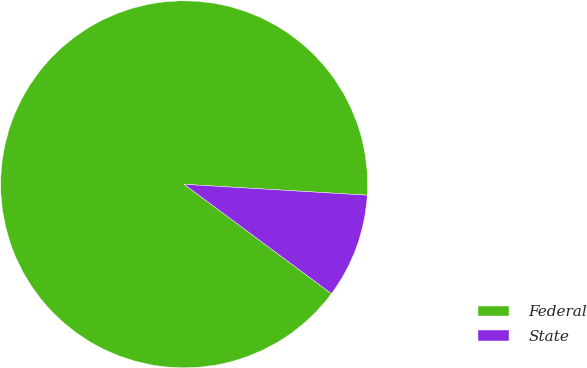<chart> <loc_0><loc_0><loc_500><loc_500><pie_chart><fcel>Federal<fcel>State<nl><fcel>90.78%<fcel>9.22%<nl></chart> 